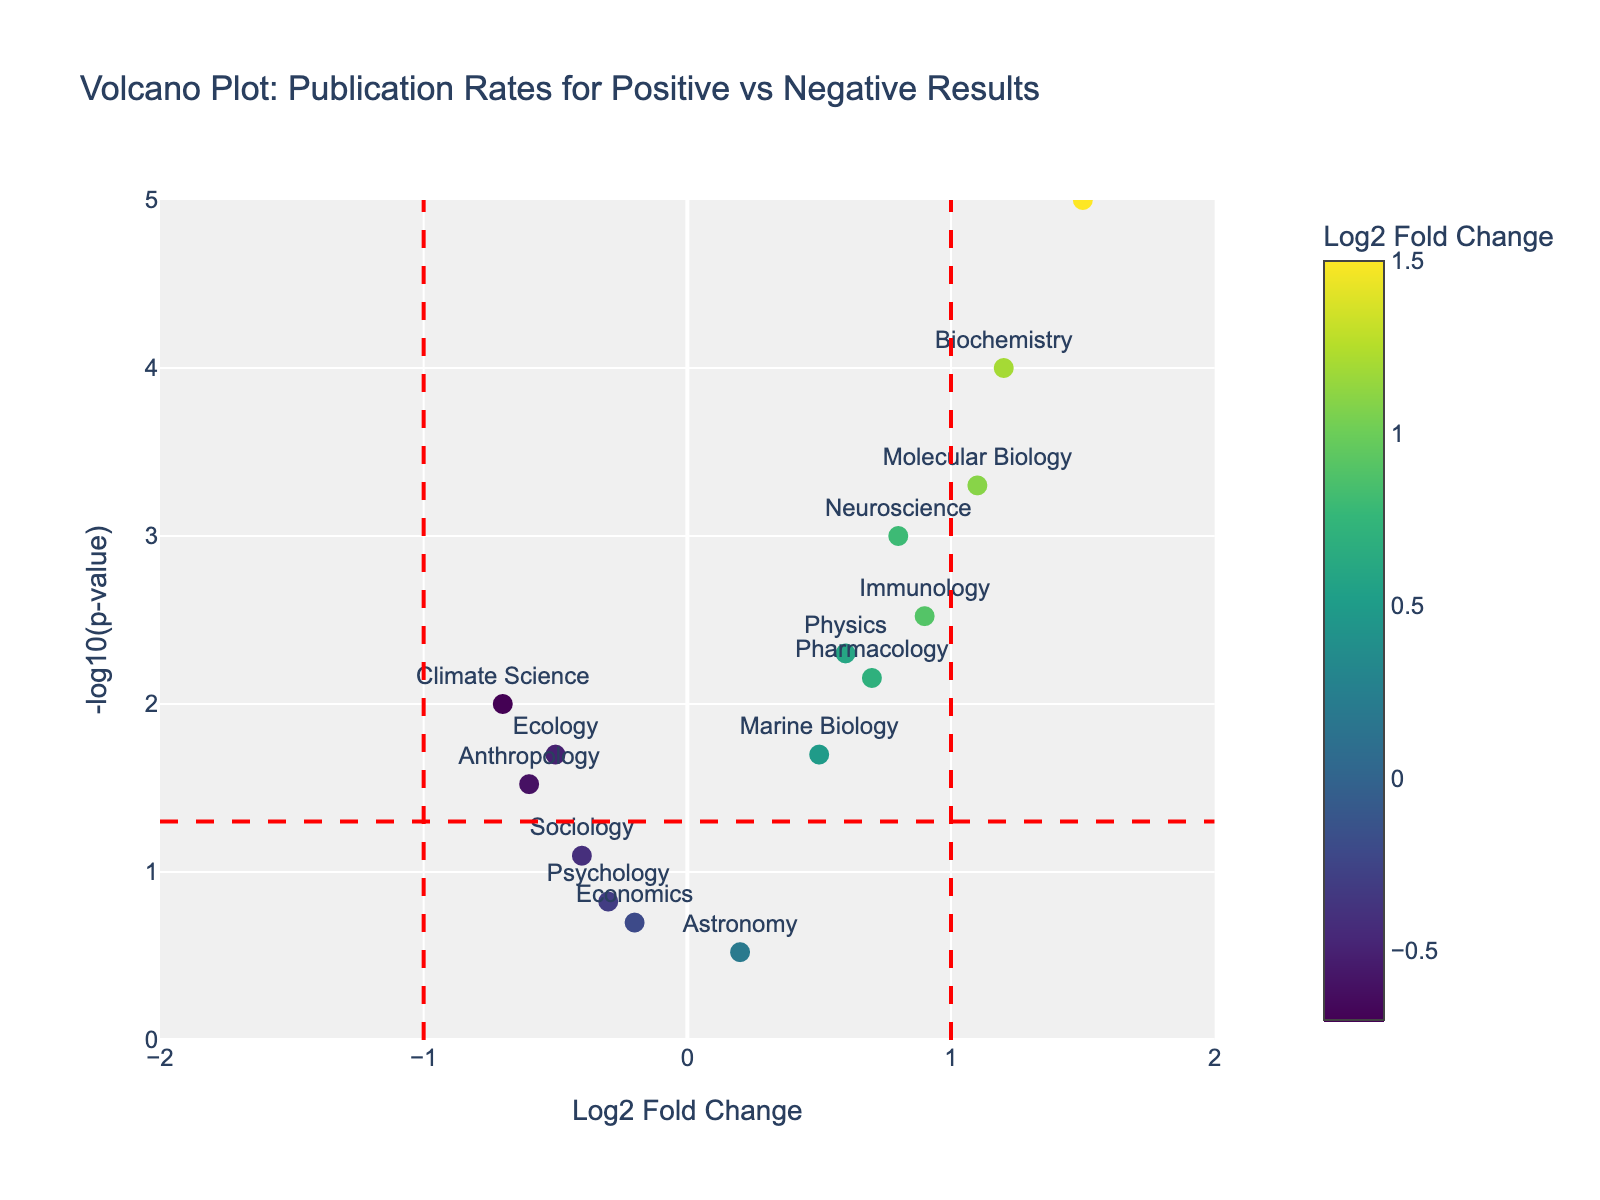What is the title of the plot? The title of the plot can be found at the top of the figure and usually describes what the plot is about. In this case, it is "Volcano Plot: Publication Rates for Positive vs Negative Results".
Answer: Volcano Plot: Publication Rates for Positive vs Negative Results Which study has the highest Log2 Fold Change? To determine this, look at the x-axis and identify the point farthest to the right. The text label should indicate the study. The study with the highest Log2 Fold Change is "Genetics" with a value of 1.5.
Answer: Genetics Which study has the lowest p-value? Look at the y-axis where the p-value is represented as -log10(p-value). The point highest on the y-axis corresponds to the lowest p-value. The study is "Genetics".
Answer: Genetics How many studies have a p-value below 0.05? A horizontal red dashed line represents -log10(0.05). Count the markers above this line to get the number of studies with p-values below 0.05. There are 9 studies above this line.
Answer: 9 What is the Log2 Fold Change and p-value for Neuroscience? Find the point labeled "Neuroscience" in the plot and refer to its hover information. The Log2 Fold Change for Neuroscience is 0.8 and the p-value is 0.001.
Answer: Log2FC: 0.8, p-value: 0.001 Which disciplines have negative Log2 Fold Change and p-values below 0.05? Identify the points to the left of the vertical dashed line at Log2FC = 0 that are above the horizontal dashed line (-log10(0.05)). These represent studies with negative Log2 Fold Change and p-values below 0.05. The disciplines are Ecology, Climate Science, and Anthropology.
Answer: Ecology, Climate Science, Anthropology What is the difference in Log2 Fold Change between Biochemistry and Ecology? The Log2 Fold Change for Biochemistry is 1.2 and for Ecology is -0.5. The difference is 1.2 - (-0.5) = 1.7.
Answer: 1.7 Which study has a Log2 Fold Change closest to zero? Look at the points near the vertical line at Log2FC = 0. "Astronomy" has a Log2 Fold Change closest to zero with a value of 0.2.
Answer: Astronomy Compare the p-values of Immunology and Pharmacology. Which one is lower? Determine the position of the points on the y-axis. Immunology is higher on the y-axis than Pharmacology, indicating a lower p-value.
Answer: Immunology Which study has the largest absolute Log2 Fold Change but a p-value greater than 0.05? Look at the points outside the vertical dashed lines (highest or lowest Log2FC) and focus on those below the horizontal dashed line (-log10(0.05)). "Psychology" fits this criterion with Log2FC = -0.3 and p-value = 0.15.
Answer: Psychology 